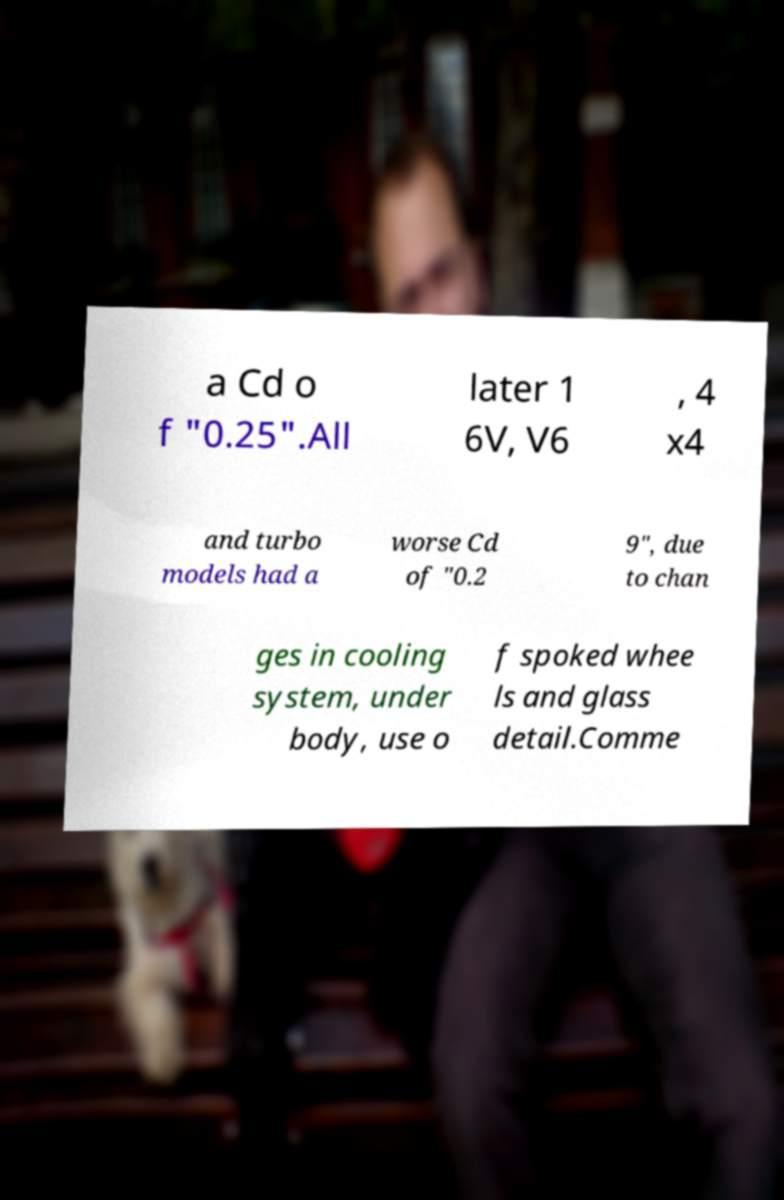Please read and relay the text visible in this image. What does it say? a Cd o f "0.25".All later 1 6V, V6 , 4 x4 and turbo models had a worse Cd of "0.2 9", due to chan ges in cooling system, under body, use o f spoked whee ls and glass detail.Comme 